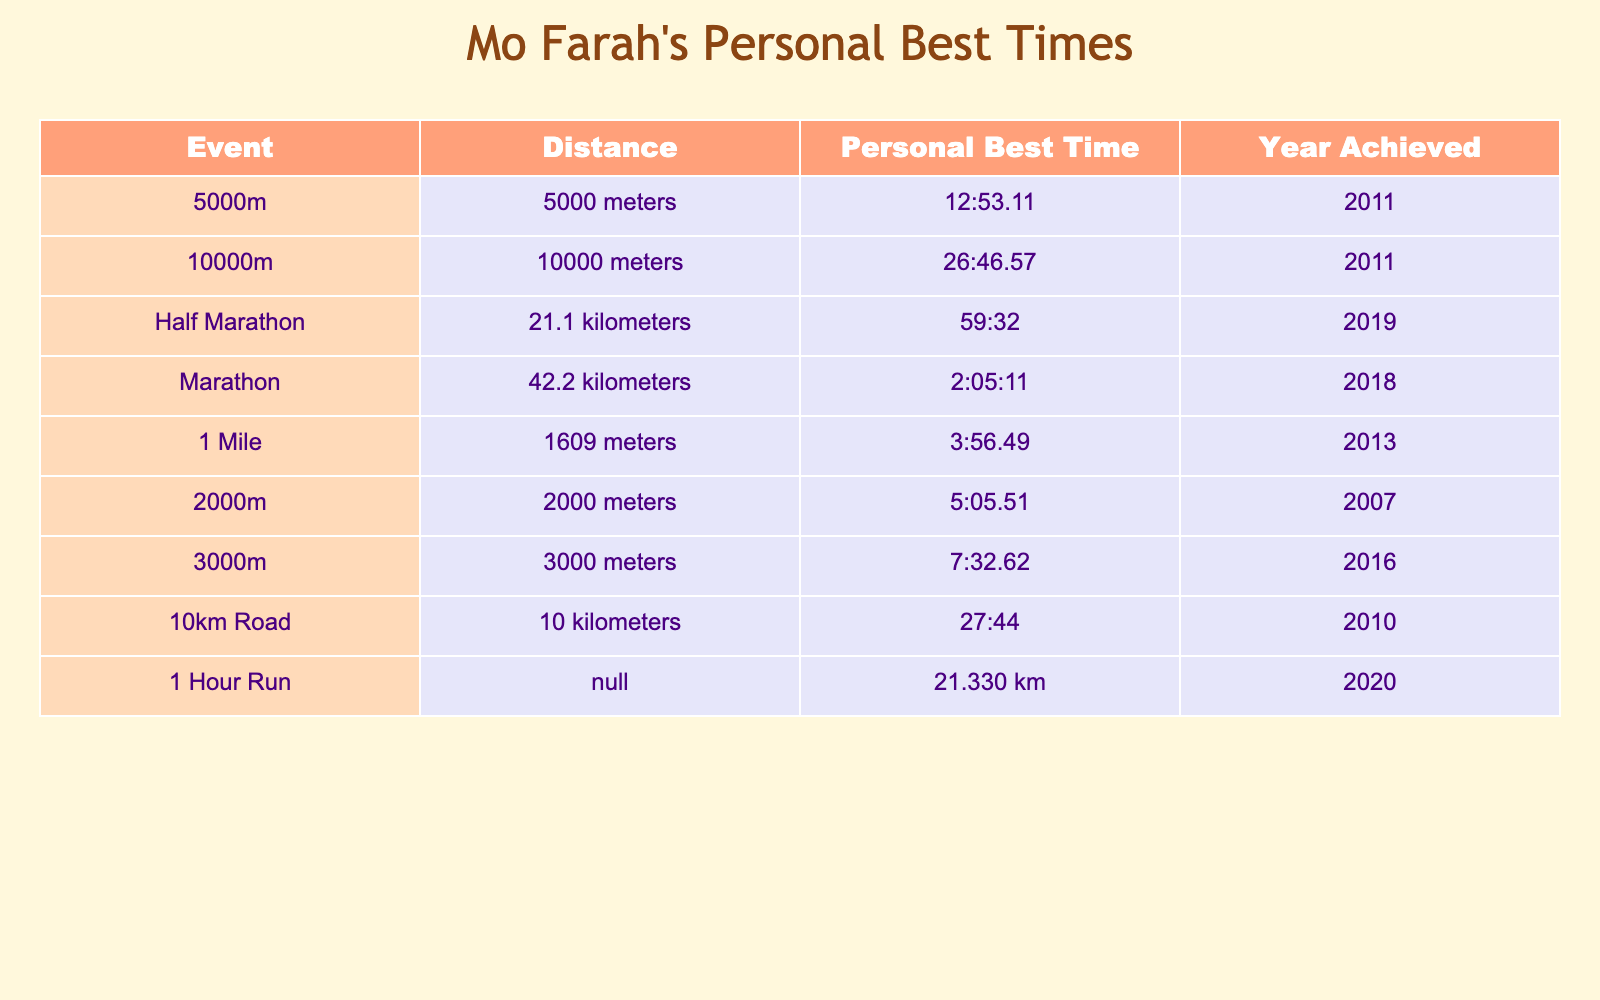What is Mo Farah's personal best time for the 5000 meters? The table lists multiple events, and for the 5000 meters, it shows the personal best time is 12:53.11.
Answer: 12:53.11 In which year did Mo Farah achieve his personal best time for the Marathon? According to the table, his personal best for the Marathon was achieved in 2018.
Answer: 2018 Which event has the longest distance in Mo Farah's personal best records? The Marathon is listed in the table with a distance of 42.2 kilometers, which is longer than any other event.
Answer: Marathon What was Mo Farah's personal best time for the Half Marathon in comparison to his 10 km Road time? The Half Marathon time is 59:32, while the 10 km Road time is 27:44. Converting the Half Marathon to an equivalent 10 km time shows it is longer, thus 59:32 is greater than 27:44.
Answer: 59:32 is greater What is the average of Mo Farah's personal best times for the 5000m and 10km Road events? For the 5000m, the best time is 12:53.11 and for the 10km Road it is 27:44. Converting each to seconds gives 773.11 seconds for 5000m and 1664 seconds for 10km. The average in seconds is (773.11 + 1664) / 2, which equals approximately 1218.56 seconds, converting back it is approximately 20:18.56.
Answer: 20:18.56 Did Mo Farah achieve his personal best in the 3000m after he set his half marathon record? The 3000m best was achieved in 2016 and the Half Marathon best in 2019. This means he did achieve the 3000m personal best before the Half Marathon record.
Answer: Yes What is the difference in personal best time between the 10000m and 5000m events? The personal best for the 10000m is 26:46.57 and for the 5000m it is 12:53.11. To find the difference, we convert them to seconds: 1606.57 seconds (10000m) - 773.11 seconds (5000m) equals about 833.46 seconds, which translates to approximately 13 minutes and 53.46 seconds difference.
Answer: 13:53.46 How many events did Mo Farah achieve a personal best in before 2015? Referring to the table, the events listed before 2015 are 5000m, 10000m, and 2000m (all achieved by 2011), totaling three events.
Answer: 3 Is it true that Mo Farah's personal best time for 1 Mile is shorter than his 2000m time? The time for 1 Mile is 3:56.49 and for 2000m it's 5:05.51. Since 3:56.49 is less than 5:05.51, the statement is true.
Answer: Yes 